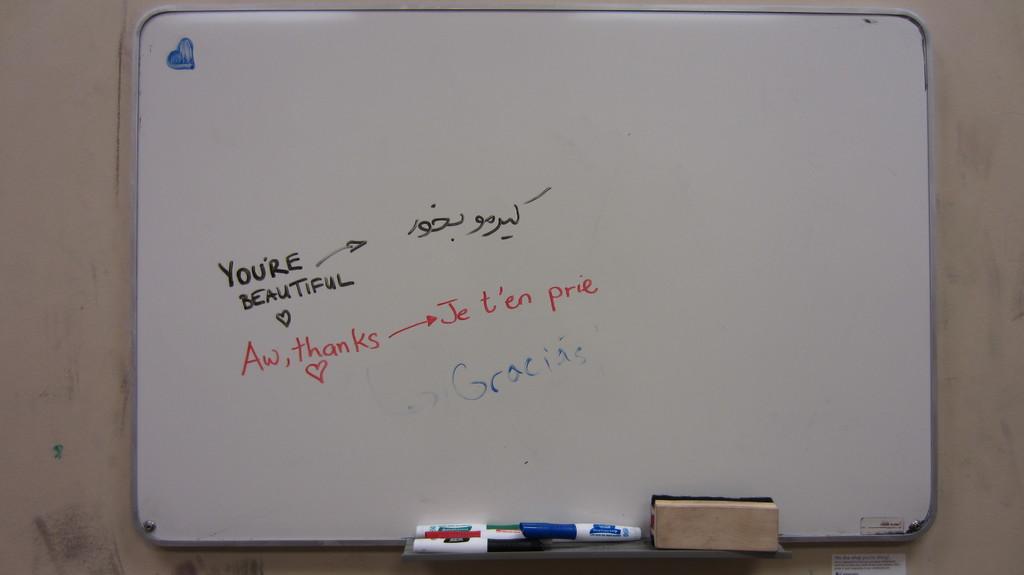Is this a french lesson?
Make the answer very short. Unanswerable. What is written in red?
Ensure brevity in your answer.  Aw, thanks je t'en prie. 